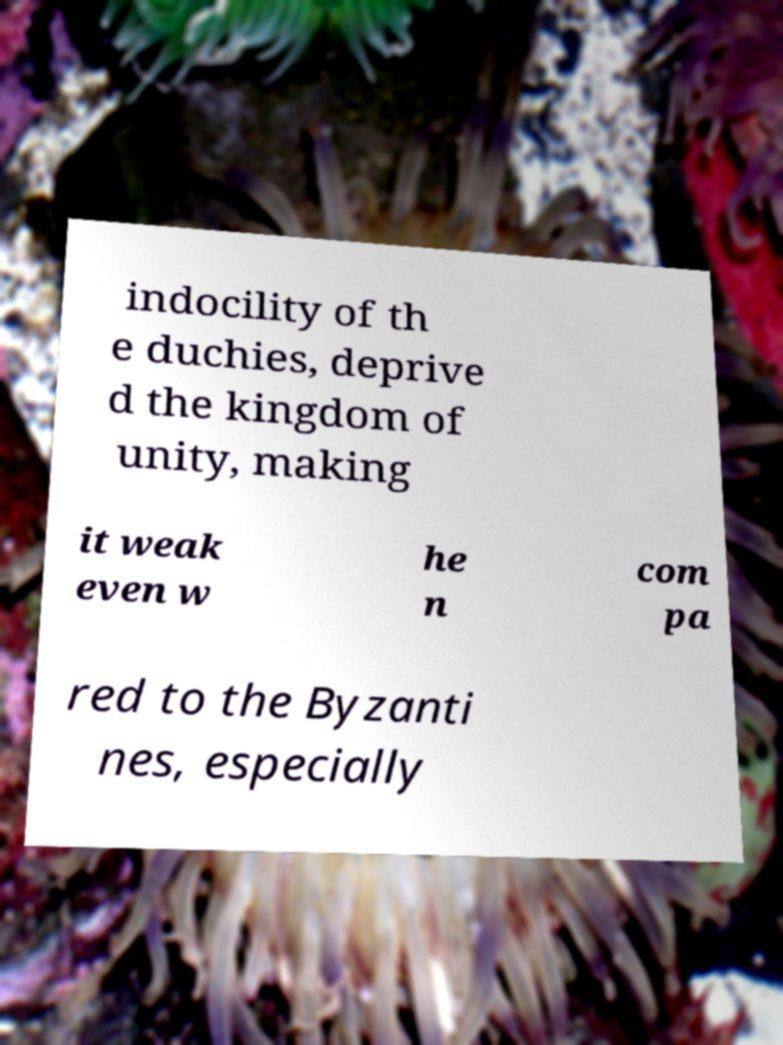What messages or text are displayed in this image? I need them in a readable, typed format. indocility of th e duchies, deprive d the kingdom of unity, making it weak even w he n com pa red to the Byzanti nes, especially 